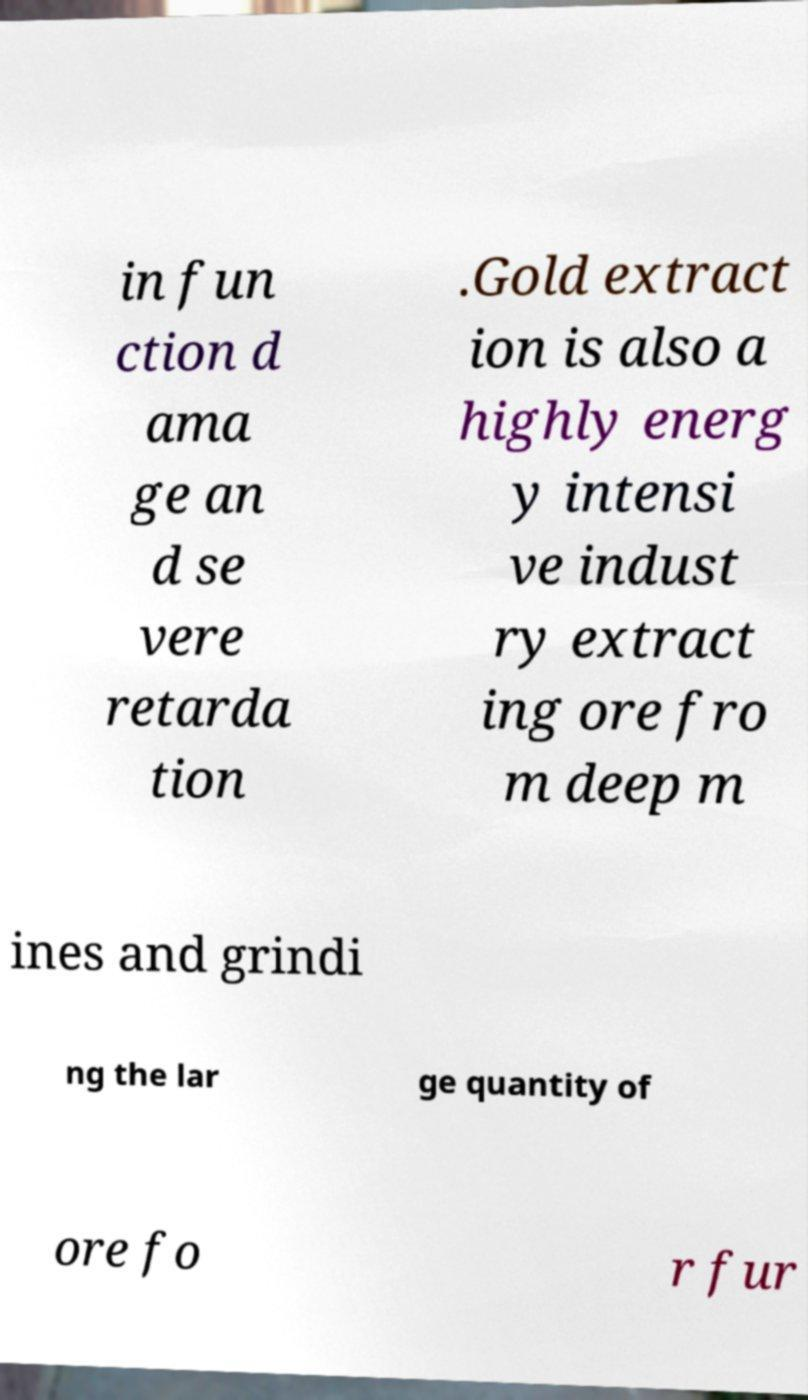Can you read and provide the text displayed in the image?This photo seems to have some interesting text. Can you extract and type it out for me? in fun ction d ama ge an d se vere retarda tion .Gold extract ion is also a highly energ y intensi ve indust ry extract ing ore fro m deep m ines and grindi ng the lar ge quantity of ore fo r fur 